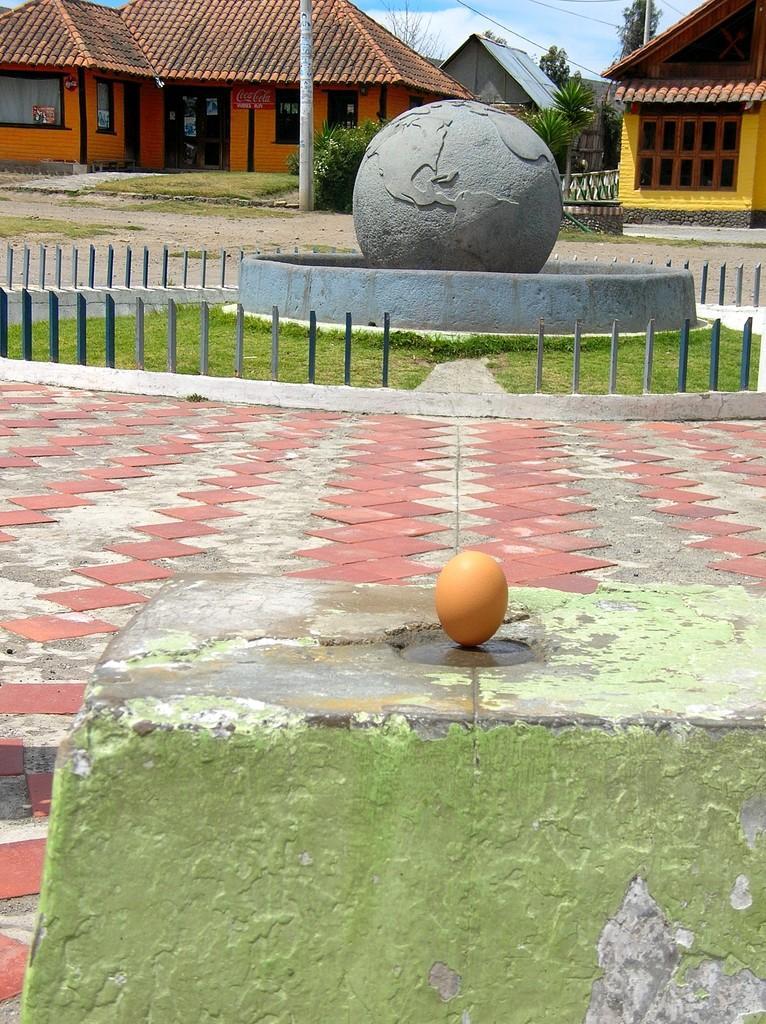Please provide a concise description of this image. In this image in the front there is an egg on the stone. In the center there is grass on the ground and there are buildings in the background, there are trees and the sky is cloudy. 